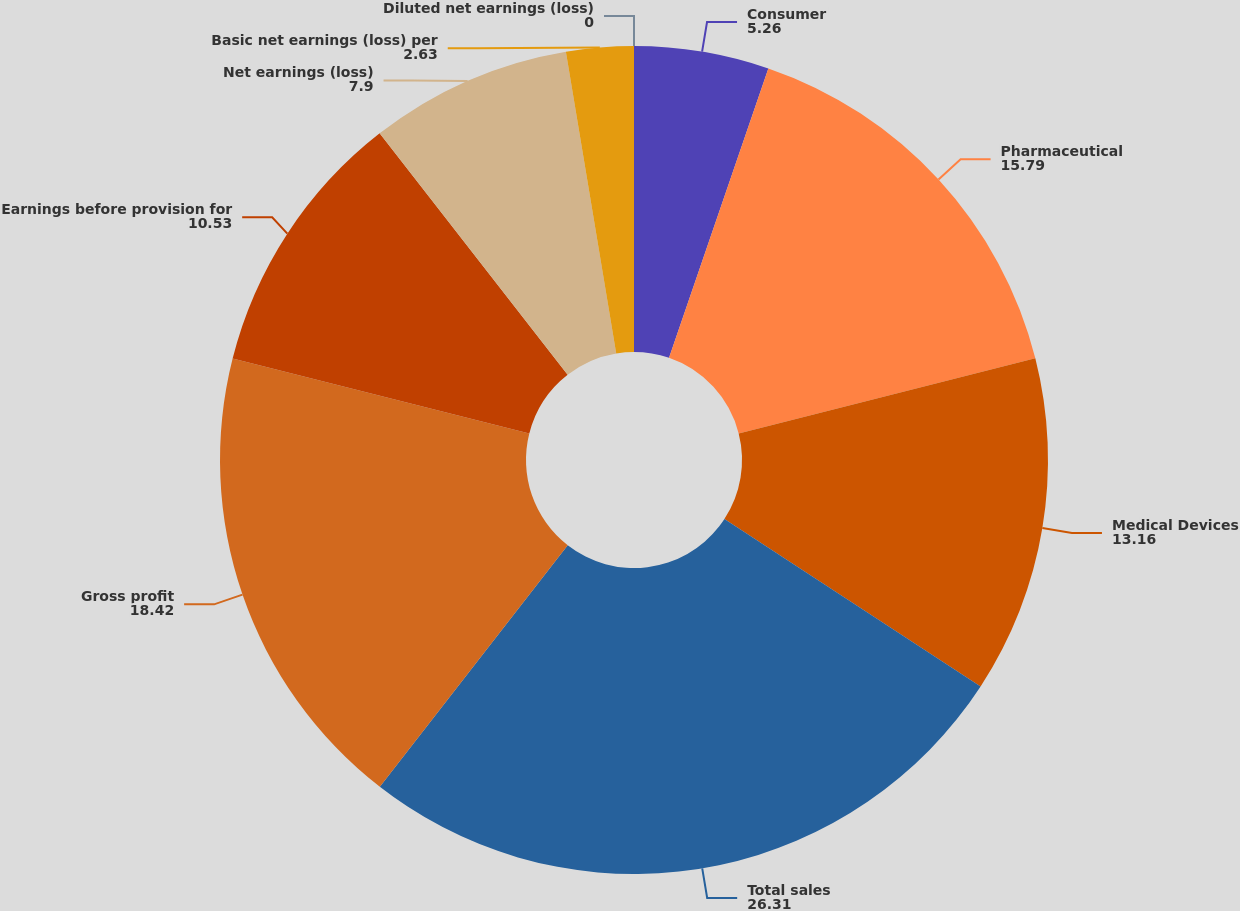<chart> <loc_0><loc_0><loc_500><loc_500><pie_chart><fcel>Consumer<fcel>Pharmaceutical<fcel>Medical Devices<fcel>Total sales<fcel>Gross profit<fcel>Earnings before provision for<fcel>Net earnings (loss)<fcel>Basic net earnings (loss) per<fcel>Diluted net earnings (loss)<nl><fcel>5.26%<fcel>15.79%<fcel>13.16%<fcel>26.31%<fcel>18.42%<fcel>10.53%<fcel>7.9%<fcel>2.63%<fcel>0.0%<nl></chart> 